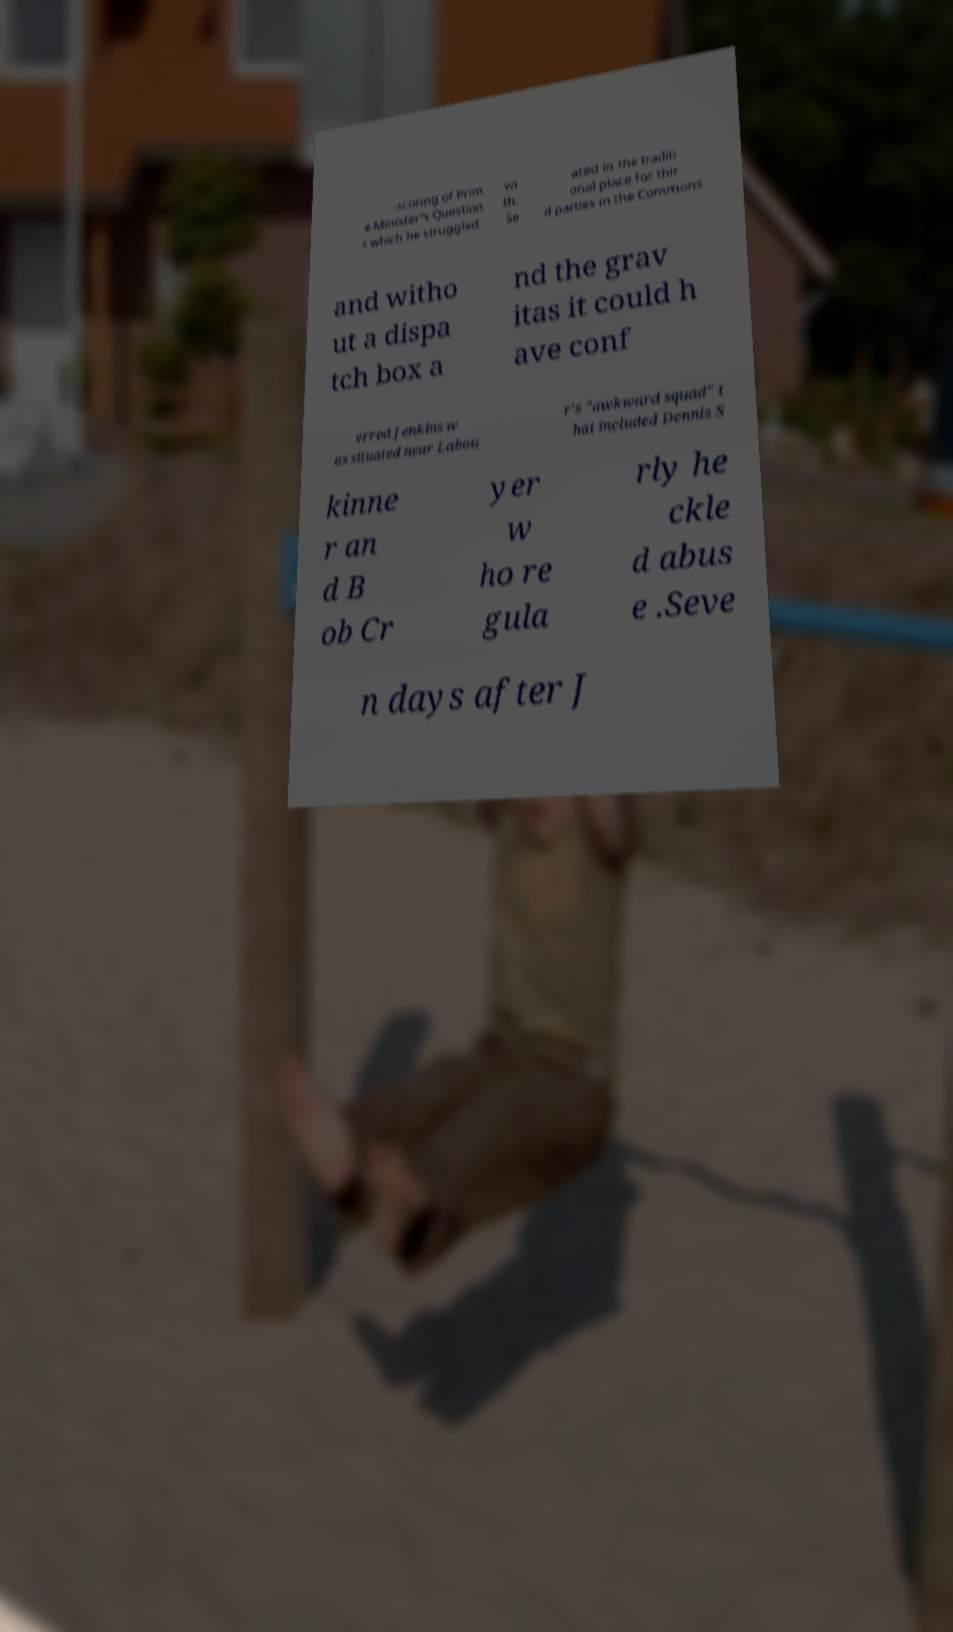I need the written content from this picture converted into text. Can you do that? -scoring of Prim e Minister's Question s which he struggled wi th. Se ated in the traditi onal place for thir d parties in the Commons and witho ut a dispa tch box a nd the grav itas it could h ave conf erred Jenkins w as situated near Labou r's "awkward squad" t hat included Dennis S kinne r an d B ob Cr yer w ho re gula rly he ckle d abus e .Seve n days after J 